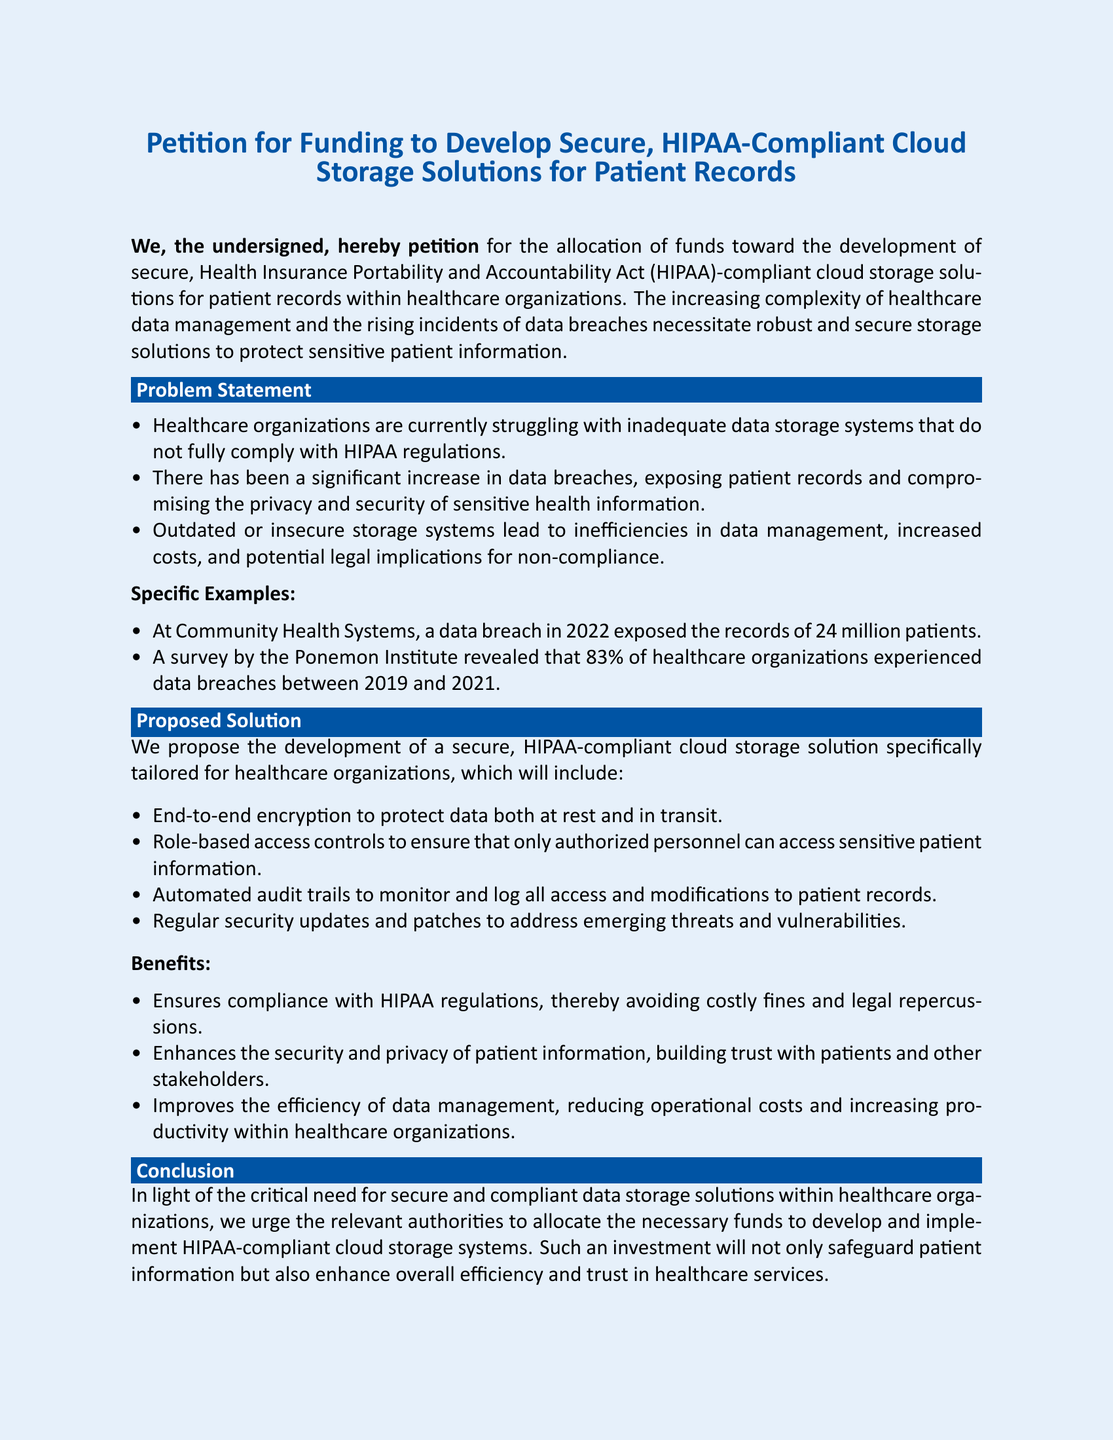What is the title of the petition? The title of the petition is presented at the top of the document as the main focus.
Answer: Petition for Funding to Develop Secure, HIPAA-Compliant Cloud Storage Solutions for Patient Records What year did a data breach occur at Community Health Systems? The document specifies the year in which the data breach happened.
Answer: 2022 What percentage of healthcare organizations experienced data breaches according to the Ponemon Institute survey? The document reveals a statistic related to data breaches in healthcare organizations.
Answer: 83% What is one proposed feature of the HIPAA-compliant cloud storage solution? The document lists several features of the proposed solution; this is one example.
Answer: End-to-end encryption What is one benefit mentioned for developing HIPAA-compliant storage solutions? The document highlights several benefits associated with the proposed solutions.
Answer: Ensures compliance with HIPAA regulations What is the main problem stated in the document? The document identifies a key issue related to healthcare organizations’ data storage.
Answer: Inadequate data storage systems Who is the audience of this petition? The document outlines who should respond to the petition's request for funding.
Answer: Relevant authorities What does the proposal aim to protect? The document describes the primary goal of the new storage solution.
Answer: Patient information 